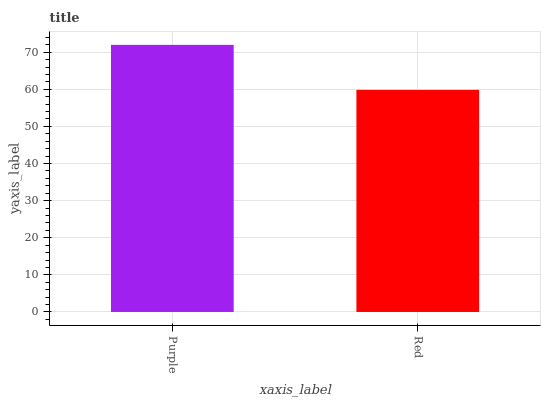Is Red the minimum?
Answer yes or no. Yes. Is Purple the maximum?
Answer yes or no. Yes. Is Red the maximum?
Answer yes or no. No. Is Purple greater than Red?
Answer yes or no. Yes. Is Red less than Purple?
Answer yes or no. Yes. Is Red greater than Purple?
Answer yes or no. No. Is Purple less than Red?
Answer yes or no. No. Is Purple the high median?
Answer yes or no. Yes. Is Red the low median?
Answer yes or no. Yes. Is Red the high median?
Answer yes or no. No. Is Purple the low median?
Answer yes or no. No. 